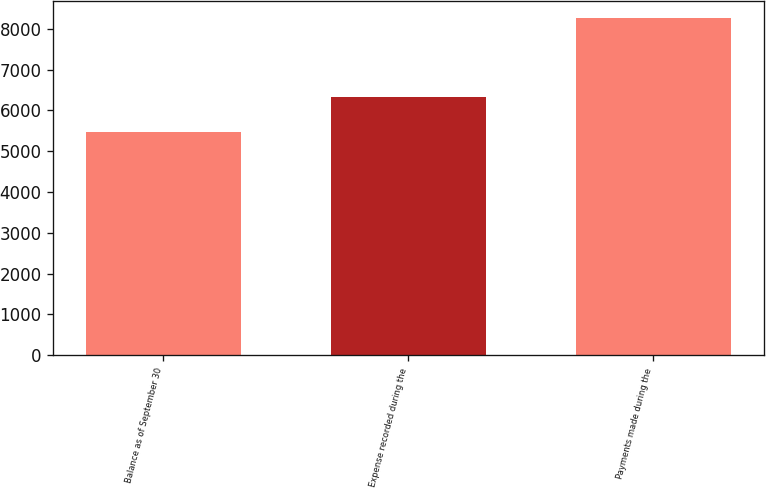Convert chart to OTSL. <chart><loc_0><loc_0><loc_500><loc_500><bar_chart><fcel>Balance as of September 30<fcel>Expense recorded during the<fcel>Payments made during the<nl><fcel>5464.1<fcel>6324<fcel>8275<nl></chart> 